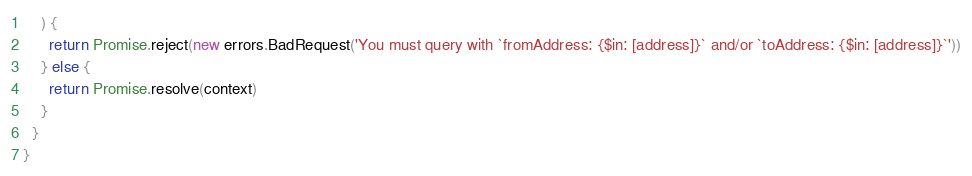<code> <loc_0><loc_0><loc_500><loc_500><_JavaScript_>    ) {
      return Promise.reject(new errors.BadRequest('You must query with `fromAddress: {$in: [address]}` and/or `toAddress: {$in: [address]}`'))
    } else {
      return Promise.resolve(context)
    }
  }
}
</code> 